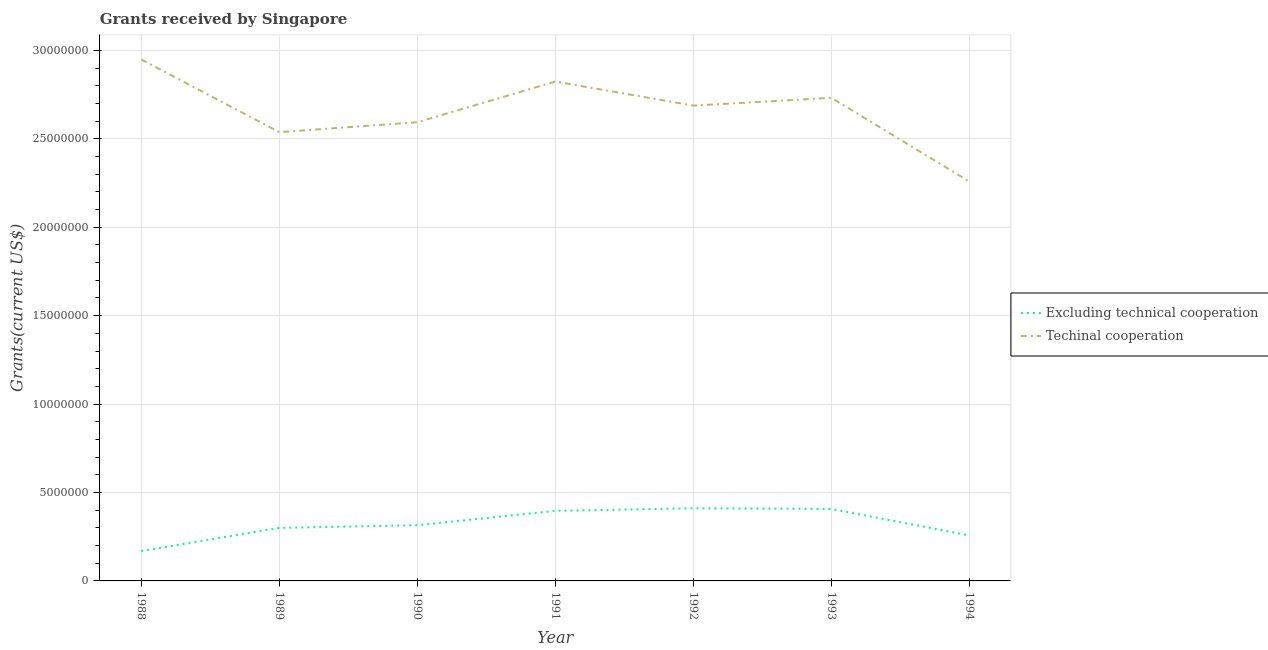What is the amount of grants received(excluding technical cooperation) in 1992?
Give a very brief answer. 4.11e+06. Across all years, what is the maximum amount of grants received(excluding technical cooperation)?
Your answer should be compact. 4.11e+06. Across all years, what is the minimum amount of grants received(including technical cooperation)?
Make the answer very short. 2.26e+07. What is the total amount of grants received(including technical cooperation) in the graph?
Keep it short and to the point. 1.86e+08. What is the difference between the amount of grants received(excluding technical cooperation) in 1988 and that in 1994?
Offer a terse response. -8.80e+05. What is the difference between the amount of grants received(including technical cooperation) in 1988 and the amount of grants received(excluding technical cooperation) in 1993?
Give a very brief answer. 2.54e+07. What is the average amount of grants received(including technical cooperation) per year?
Offer a very short reply. 2.65e+07. In the year 1993, what is the difference between the amount of grants received(including technical cooperation) and amount of grants received(excluding technical cooperation)?
Offer a very short reply. 2.32e+07. In how many years, is the amount of grants received(including technical cooperation) greater than 25000000 US$?
Offer a terse response. 6. What is the ratio of the amount of grants received(excluding technical cooperation) in 1991 to that in 1993?
Ensure brevity in your answer.  0.97. Is the amount of grants received(excluding technical cooperation) in 1990 less than that in 1994?
Your answer should be compact. No. Is the difference between the amount of grants received(excluding technical cooperation) in 1989 and 1993 greater than the difference between the amount of grants received(including technical cooperation) in 1989 and 1993?
Make the answer very short. Yes. What is the difference between the highest and the second highest amount of grants received(excluding technical cooperation)?
Keep it short and to the point. 4.00e+04. What is the difference between the highest and the lowest amount of grants received(excluding technical cooperation)?
Ensure brevity in your answer.  2.42e+06. In how many years, is the amount of grants received(including technical cooperation) greater than the average amount of grants received(including technical cooperation) taken over all years?
Your answer should be very brief. 4. Does the amount of grants received(excluding technical cooperation) monotonically increase over the years?
Your answer should be very brief. No. Is the amount of grants received(excluding technical cooperation) strictly greater than the amount of grants received(including technical cooperation) over the years?
Offer a terse response. No. Is the amount of grants received(including technical cooperation) strictly less than the amount of grants received(excluding technical cooperation) over the years?
Ensure brevity in your answer.  No. How many lines are there?
Your answer should be very brief. 2. What is the difference between two consecutive major ticks on the Y-axis?
Ensure brevity in your answer.  5.00e+06. Does the graph contain any zero values?
Offer a very short reply. No. How many legend labels are there?
Offer a terse response. 2. How are the legend labels stacked?
Provide a succinct answer. Vertical. What is the title of the graph?
Make the answer very short. Grants received by Singapore. Does "RDB concessional" appear as one of the legend labels in the graph?
Your answer should be very brief. No. What is the label or title of the Y-axis?
Ensure brevity in your answer.  Grants(current US$). What is the Grants(current US$) of Excluding technical cooperation in 1988?
Provide a short and direct response. 1.69e+06. What is the Grants(current US$) of Techinal cooperation in 1988?
Your answer should be very brief. 2.95e+07. What is the Grants(current US$) of Techinal cooperation in 1989?
Give a very brief answer. 2.54e+07. What is the Grants(current US$) in Excluding technical cooperation in 1990?
Your answer should be compact. 3.15e+06. What is the Grants(current US$) in Techinal cooperation in 1990?
Keep it short and to the point. 2.59e+07. What is the Grants(current US$) of Excluding technical cooperation in 1991?
Offer a terse response. 3.96e+06. What is the Grants(current US$) of Techinal cooperation in 1991?
Your response must be concise. 2.82e+07. What is the Grants(current US$) in Excluding technical cooperation in 1992?
Give a very brief answer. 4.11e+06. What is the Grants(current US$) of Techinal cooperation in 1992?
Your answer should be compact. 2.69e+07. What is the Grants(current US$) in Excluding technical cooperation in 1993?
Make the answer very short. 4.07e+06. What is the Grants(current US$) of Techinal cooperation in 1993?
Provide a short and direct response. 2.73e+07. What is the Grants(current US$) of Excluding technical cooperation in 1994?
Give a very brief answer. 2.57e+06. What is the Grants(current US$) in Techinal cooperation in 1994?
Your answer should be very brief. 2.26e+07. Across all years, what is the maximum Grants(current US$) in Excluding technical cooperation?
Keep it short and to the point. 4.11e+06. Across all years, what is the maximum Grants(current US$) in Techinal cooperation?
Offer a very short reply. 2.95e+07. Across all years, what is the minimum Grants(current US$) in Excluding technical cooperation?
Provide a succinct answer. 1.69e+06. Across all years, what is the minimum Grants(current US$) of Techinal cooperation?
Provide a short and direct response. 2.26e+07. What is the total Grants(current US$) in Excluding technical cooperation in the graph?
Offer a very short reply. 2.26e+07. What is the total Grants(current US$) in Techinal cooperation in the graph?
Provide a short and direct response. 1.86e+08. What is the difference between the Grants(current US$) in Excluding technical cooperation in 1988 and that in 1989?
Give a very brief answer. -1.31e+06. What is the difference between the Grants(current US$) in Techinal cooperation in 1988 and that in 1989?
Give a very brief answer. 4.11e+06. What is the difference between the Grants(current US$) of Excluding technical cooperation in 1988 and that in 1990?
Your answer should be very brief. -1.46e+06. What is the difference between the Grants(current US$) in Techinal cooperation in 1988 and that in 1990?
Offer a terse response. 3.55e+06. What is the difference between the Grants(current US$) in Excluding technical cooperation in 1988 and that in 1991?
Your answer should be very brief. -2.27e+06. What is the difference between the Grants(current US$) of Techinal cooperation in 1988 and that in 1991?
Your answer should be very brief. 1.25e+06. What is the difference between the Grants(current US$) in Excluding technical cooperation in 1988 and that in 1992?
Provide a short and direct response. -2.42e+06. What is the difference between the Grants(current US$) of Techinal cooperation in 1988 and that in 1992?
Keep it short and to the point. 2.61e+06. What is the difference between the Grants(current US$) of Excluding technical cooperation in 1988 and that in 1993?
Your answer should be very brief. -2.38e+06. What is the difference between the Grants(current US$) of Techinal cooperation in 1988 and that in 1993?
Offer a very short reply. 2.17e+06. What is the difference between the Grants(current US$) in Excluding technical cooperation in 1988 and that in 1994?
Provide a succinct answer. -8.80e+05. What is the difference between the Grants(current US$) in Techinal cooperation in 1988 and that in 1994?
Make the answer very short. 6.91e+06. What is the difference between the Grants(current US$) of Excluding technical cooperation in 1989 and that in 1990?
Ensure brevity in your answer.  -1.50e+05. What is the difference between the Grants(current US$) in Techinal cooperation in 1989 and that in 1990?
Make the answer very short. -5.60e+05. What is the difference between the Grants(current US$) in Excluding technical cooperation in 1989 and that in 1991?
Give a very brief answer. -9.60e+05. What is the difference between the Grants(current US$) in Techinal cooperation in 1989 and that in 1991?
Your answer should be compact. -2.86e+06. What is the difference between the Grants(current US$) in Excluding technical cooperation in 1989 and that in 1992?
Provide a short and direct response. -1.11e+06. What is the difference between the Grants(current US$) in Techinal cooperation in 1989 and that in 1992?
Give a very brief answer. -1.50e+06. What is the difference between the Grants(current US$) of Excluding technical cooperation in 1989 and that in 1993?
Make the answer very short. -1.07e+06. What is the difference between the Grants(current US$) in Techinal cooperation in 1989 and that in 1993?
Provide a succinct answer. -1.94e+06. What is the difference between the Grants(current US$) of Techinal cooperation in 1989 and that in 1994?
Offer a terse response. 2.80e+06. What is the difference between the Grants(current US$) of Excluding technical cooperation in 1990 and that in 1991?
Provide a succinct answer. -8.10e+05. What is the difference between the Grants(current US$) of Techinal cooperation in 1990 and that in 1991?
Your answer should be compact. -2.30e+06. What is the difference between the Grants(current US$) in Excluding technical cooperation in 1990 and that in 1992?
Ensure brevity in your answer.  -9.60e+05. What is the difference between the Grants(current US$) of Techinal cooperation in 1990 and that in 1992?
Keep it short and to the point. -9.40e+05. What is the difference between the Grants(current US$) of Excluding technical cooperation in 1990 and that in 1993?
Ensure brevity in your answer.  -9.20e+05. What is the difference between the Grants(current US$) in Techinal cooperation in 1990 and that in 1993?
Make the answer very short. -1.38e+06. What is the difference between the Grants(current US$) in Excluding technical cooperation in 1990 and that in 1994?
Ensure brevity in your answer.  5.80e+05. What is the difference between the Grants(current US$) in Techinal cooperation in 1990 and that in 1994?
Give a very brief answer. 3.36e+06. What is the difference between the Grants(current US$) of Techinal cooperation in 1991 and that in 1992?
Your response must be concise. 1.36e+06. What is the difference between the Grants(current US$) of Techinal cooperation in 1991 and that in 1993?
Offer a terse response. 9.20e+05. What is the difference between the Grants(current US$) in Excluding technical cooperation in 1991 and that in 1994?
Offer a terse response. 1.39e+06. What is the difference between the Grants(current US$) in Techinal cooperation in 1991 and that in 1994?
Give a very brief answer. 5.66e+06. What is the difference between the Grants(current US$) of Excluding technical cooperation in 1992 and that in 1993?
Keep it short and to the point. 4.00e+04. What is the difference between the Grants(current US$) in Techinal cooperation in 1992 and that in 1993?
Make the answer very short. -4.40e+05. What is the difference between the Grants(current US$) in Excluding technical cooperation in 1992 and that in 1994?
Provide a succinct answer. 1.54e+06. What is the difference between the Grants(current US$) in Techinal cooperation in 1992 and that in 1994?
Give a very brief answer. 4.30e+06. What is the difference between the Grants(current US$) of Excluding technical cooperation in 1993 and that in 1994?
Offer a terse response. 1.50e+06. What is the difference between the Grants(current US$) of Techinal cooperation in 1993 and that in 1994?
Keep it short and to the point. 4.74e+06. What is the difference between the Grants(current US$) in Excluding technical cooperation in 1988 and the Grants(current US$) in Techinal cooperation in 1989?
Provide a succinct answer. -2.37e+07. What is the difference between the Grants(current US$) of Excluding technical cooperation in 1988 and the Grants(current US$) of Techinal cooperation in 1990?
Make the answer very short. -2.42e+07. What is the difference between the Grants(current US$) of Excluding technical cooperation in 1988 and the Grants(current US$) of Techinal cooperation in 1991?
Provide a succinct answer. -2.66e+07. What is the difference between the Grants(current US$) of Excluding technical cooperation in 1988 and the Grants(current US$) of Techinal cooperation in 1992?
Give a very brief answer. -2.52e+07. What is the difference between the Grants(current US$) in Excluding technical cooperation in 1988 and the Grants(current US$) in Techinal cooperation in 1993?
Make the answer very short. -2.56e+07. What is the difference between the Grants(current US$) in Excluding technical cooperation in 1988 and the Grants(current US$) in Techinal cooperation in 1994?
Your answer should be compact. -2.09e+07. What is the difference between the Grants(current US$) in Excluding technical cooperation in 1989 and the Grants(current US$) in Techinal cooperation in 1990?
Provide a short and direct response. -2.29e+07. What is the difference between the Grants(current US$) of Excluding technical cooperation in 1989 and the Grants(current US$) of Techinal cooperation in 1991?
Make the answer very short. -2.52e+07. What is the difference between the Grants(current US$) of Excluding technical cooperation in 1989 and the Grants(current US$) of Techinal cooperation in 1992?
Ensure brevity in your answer.  -2.39e+07. What is the difference between the Grants(current US$) of Excluding technical cooperation in 1989 and the Grants(current US$) of Techinal cooperation in 1993?
Offer a very short reply. -2.43e+07. What is the difference between the Grants(current US$) of Excluding technical cooperation in 1989 and the Grants(current US$) of Techinal cooperation in 1994?
Your response must be concise. -1.96e+07. What is the difference between the Grants(current US$) in Excluding technical cooperation in 1990 and the Grants(current US$) in Techinal cooperation in 1991?
Provide a succinct answer. -2.51e+07. What is the difference between the Grants(current US$) of Excluding technical cooperation in 1990 and the Grants(current US$) of Techinal cooperation in 1992?
Your answer should be compact. -2.37e+07. What is the difference between the Grants(current US$) of Excluding technical cooperation in 1990 and the Grants(current US$) of Techinal cooperation in 1993?
Offer a very short reply. -2.42e+07. What is the difference between the Grants(current US$) in Excluding technical cooperation in 1990 and the Grants(current US$) in Techinal cooperation in 1994?
Offer a terse response. -1.94e+07. What is the difference between the Grants(current US$) in Excluding technical cooperation in 1991 and the Grants(current US$) in Techinal cooperation in 1992?
Make the answer very short. -2.29e+07. What is the difference between the Grants(current US$) of Excluding technical cooperation in 1991 and the Grants(current US$) of Techinal cooperation in 1993?
Offer a very short reply. -2.34e+07. What is the difference between the Grants(current US$) of Excluding technical cooperation in 1991 and the Grants(current US$) of Techinal cooperation in 1994?
Provide a short and direct response. -1.86e+07. What is the difference between the Grants(current US$) in Excluding technical cooperation in 1992 and the Grants(current US$) in Techinal cooperation in 1993?
Your answer should be compact. -2.32e+07. What is the difference between the Grants(current US$) in Excluding technical cooperation in 1992 and the Grants(current US$) in Techinal cooperation in 1994?
Make the answer very short. -1.85e+07. What is the difference between the Grants(current US$) of Excluding technical cooperation in 1993 and the Grants(current US$) of Techinal cooperation in 1994?
Offer a terse response. -1.85e+07. What is the average Grants(current US$) in Excluding technical cooperation per year?
Provide a succinct answer. 3.22e+06. What is the average Grants(current US$) in Techinal cooperation per year?
Ensure brevity in your answer.  2.65e+07. In the year 1988, what is the difference between the Grants(current US$) in Excluding technical cooperation and Grants(current US$) in Techinal cooperation?
Ensure brevity in your answer.  -2.78e+07. In the year 1989, what is the difference between the Grants(current US$) in Excluding technical cooperation and Grants(current US$) in Techinal cooperation?
Offer a terse response. -2.24e+07. In the year 1990, what is the difference between the Grants(current US$) of Excluding technical cooperation and Grants(current US$) of Techinal cooperation?
Give a very brief answer. -2.28e+07. In the year 1991, what is the difference between the Grants(current US$) of Excluding technical cooperation and Grants(current US$) of Techinal cooperation?
Your response must be concise. -2.43e+07. In the year 1992, what is the difference between the Grants(current US$) of Excluding technical cooperation and Grants(current US$) of Techinal cooperation?
Offer a terse response. -2.28e+07. In the year 1993, what is the difference between the Grants(current US$) in Excluding technical cooperation and Grants(current US$) in Techinal cooperation?
Give a very brief answer. -2.32e+07. In the year 1994, what is the difference between the Grants(current US$) of Excluding technical cooperation and Grants(current US$) of Techinal cooperation?
Provide a short and direct response. -2.00e+07. What is the ratio of the Grants(current US$) in Excluding technical cooperation in 1988 to that in 1989?
Your answer should be compact. 0.56. What is the ratio of the Grants(current US$) in Techinal cooperation in 1988 to that in 1989?
Provide a short and direct response. 1.16. What is the ratio of the Grants(current US$) in Excluding technical cooperation in 1988 to that in 1990?
Your answer should be very brief. 0.54. What is the ratio of the Grants(current US$) of Techinal cooperation in 1988 to that in 1990?
Ensure brevity in your answer.  1.14. What is the ratio of the Grants(current US$) of Excluding technical cooperation in 1988 to that in 1991?
Provide a succinct answer. 0.43. What is the ratio of the Grants(current US$) of Techinal cooperation in 1988 to that in 1991?
Your response must be concise. 1.04. What is the ratio of the Grants(current US$) in Excluding technical cooperation in 1988 to that in 1992?
Provide a succinct answer. 0.41. What is the ratio of the Grants(current US$) in Techinal cooperation in 1988 to that in 1992?
Provide a short and direct response. 1.1. What is the ratio of the Grants(current US$) in Excluding technical cooperation in 1988 to that in 1993?
Provide a succinct answer. 0.42. What is the ratio of the Grants(current US$) in Techinal cooperation in 1988 to that in 1993?
Your answer should be compact. 1.08. What is the ratio of the Grants(current US$) in Excluding technical cooperation in 1988 to that in 1994?
Give a very brief answer. 0.66. What is the ratio of the Grants(current US$) in Techinal cooperation in 1988 to that in 1994?
Your response must be concise. 1.31. What is the ratio of the Grants(current US$) in Excluding technical cooperation in 1989 to that in 1990?
Offer a very short reply. 0.95. What is the ratio of the Grants(current US$) in Techinal cooperation in 1989 to that in 1990?
Provide a short and direct response. 0.98. What is the ratio of the Grants(current US$) of Excluding technical cooperation in 1989 to that in 1991?
Offer a terse response. 0.76. What is the ratio of the Grants(current US$) of Techinal cooperation in 1989 to that in 1991?
Ensure brevity in your answer.  0.9. What is the ratio of the Grants(current US$) of Excluding technical cooperation in 1989 to that in 1992?
Ensure brevity in your answer.  0.73. What is the ratio of the Grants(current US$) of Techinal cooperation in 1989 to that in 1992?
Your response must be concise. 0.94. What is the ratio of the Grants(current US$) of Excluding technical cooperation in 1989 to that in 1993?
Your response must be concise. 0.74. What is the ratio of the Grants(current US$) of Techinal cooperation in 1989 to that in 1993?
Your answer should be compact. 0.93. What is the ratio of the Grants(current US$) of Excluding technical cooperation in 1989 to that in 1994?
Give a very brief answer. 1.17. What is the ratio of the Grants(current US$) of Techinal cooperation in 1989 to that in 1994?
Offer a terse response. 1.12. What is the ratio of the Grants(current US$) of Excluding technical cooperation in 1990 to that in 1991?
Make the answer very short. 0.8. What is the ratio of the Grants(current US$) in Techinal cooperation in 1990 to that in 1991?
Provide a short and direct response. 0.92. What is the ratio of the Grants(current US$) of Excluding technical cooperation in 1990 to that in 1992?
Your answer should be compact. 0.77. What is the ratio of the Grants(current US$) of Techinal cooperation in 1990 to that in 1992?
Keep it short and to the point. 0.96. What is the ratio of the Grants(current US$) of Excluding technical cooperation in 1990 to that in 1993?
Offer a terse response. 0.77. What is the ratio of the Grants(current US$) in Techinal cooperation in 1990 to that in 1993?
Your answer should be compact. 0.95. What is the ratio of the Grants(current US$) in Excluding technical cooperation in 1990 to that in 1994?
Provide a succinct answer. 1.23. What is the ratio of the Grants(current US$) in Techinal cooperation in 1990 to that in 1994?
Keep it short and to the point. 1.15. What is the ratio of the Grants(current US$) in Excluding technical cooperation in 1991 to that in 1992?
Ensure brevity in your answer.  0.96. What is the ratio of the Grants(current US$) in Techinal cooperation in 1991 to that in 1992?
Your answer should be very brief. 1.05. What is the ratio of the Grants(current US$) in Excluding technical cooperation in 1991 to that in 1993?
Ensure brevity in your answer.  0.97. What is the ratio of the Grants(current US$) of Techinal cooperation in 1991 to that in 1993?
Offer a very short reply. 1.03. What is the ratio of the Grants(current US$) in Excluding technical cooperation in 1991 to that in 1994?
Give a very brief answer. 1.54. What is the ratio of the Grants(current US$) in Techinal cooperation in 1991 to that in 1994?
Ensure brevity in your answer.  1.25. What is the ratio of the Grants(current US$) of Excluding technical cooperation in 1992 to that in 1993?
Give a very brief answer. 1.01. What is the ratio of the Grants(current US$) in Techinal cooperation in 1992 to that in 1993?
Ensure brevity in your answer.  0.98. What is the ratio of the Grants(current US$) in Excluding technical cooperation in 1992 to that in 1994?
Your answer should be very brief. 1.6. What is the ratio of the Grants(current US$) of Techinal cooperation in 1992 to that in 1994?
Offer a terse response. 1.19. What is the ratio of the Grants(current US$) of Excluding technical cooperation in 1993 to that in 1994?
Ensure brevity in your answer.  1.58. What is the ratio of the Grants(current US$) in Techinal cooperation in 1993 to that in 1994?
Offer a terse response. 1.21. What is the difference between the highest and the second highest Grants(current US$) of Excluding technical cooperation?
Offer a terse response. 4.00e+04. What is the difference between the highest and the second highest Grants(current US$) in Techinal cooperation?
Make the answer very short. 1.25e+06. What is the difference between the highest and the lowest Grants(current US$) in Excluding technical cooperation?
Provide a short and direct response. 2.42e+06. What is the difference between the highest and the lowest Grants(current US$) of Techinal cooperation?
Ensure brevity in your answer.  6.91e+06. 